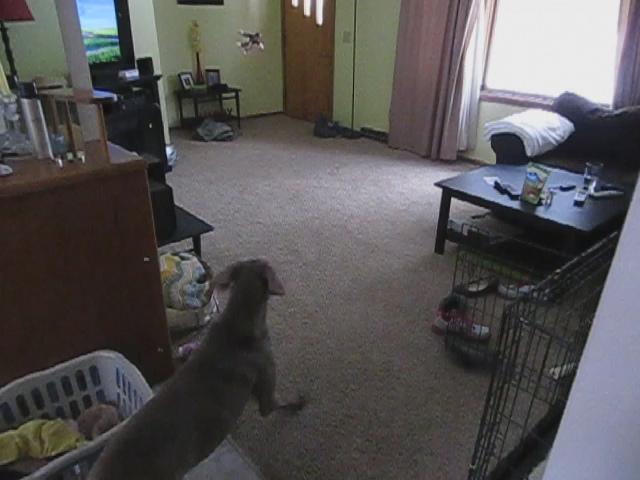What is showing in the photo?
Give a very brief answer. Dog. What is the beige dog doing?
Short answer required. Walking. Is the dog on a leech?
Quick response, please. No. What type of stuffed animal in on the floor?
Write a very short answer. None. Is the clothes basket empty?
Be succinct. No. Is the dog on the floor?
Keep it brief. Yes. What is the floor made out of?
Short answer required. Carpet. What color is the dog?
Short answer required. Gray. Which animal is in the photo?
Write a very short answer. Dog. What are the floors made of?
Keep it brief. Carpet. What is the brown object behind the dog?
Keep it brief. Dresser. Is there carpeting on the floor?
Give a very brief answer. Yes. Is the dog eating table food?
Short answer required. No. Are there bars on the window?
Quick response, please. No. 